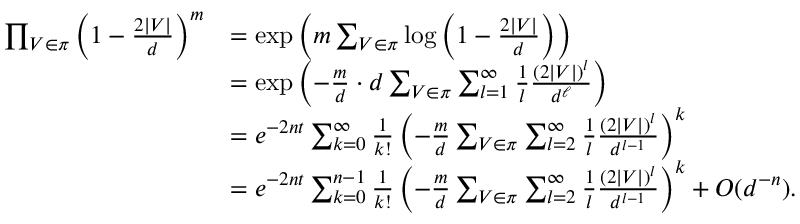<formula> <loc_0><loc_0><loc_500><loc_500>\begin{array} { r l } { \prod _ { V \in \pi } \left ( 1 - \frac { 2 | V | } { d } \right ) ^ { m } } & { = \exp \left ( m \sum _ { V \in \pi } \log \left ( 1 - \frac { 2 | V | } { d } \right ) \right ) } \\ & { = \exp \left ( - \frac { m } { d } \cdot d \sum _ { V \in \pi } \sum _ { l = 1 } ^ { \infty } \frac { 1 } { l } \frac { ( 2 | V | ) ^ { l } } { d ^ { \ell } } \right ) } \\ & { = e ^ { - 2 n t } \sum _ { k = 0 } ^ { \infty } \frac { 1 } { k ! } \left ( - \frac { m } { d } \sum _ { V \in \pi } \sum _ { l = 2 } ^ { \infty } \frac { 1 } { l } \frac { ( 2 | V | ) ^ { l } } { d ^ { l - 1 } } \right ) ^ { k } } \\ & { = e ^ { - 2 n t } \sum _ { k = 0 } ^ { n - 1 } \frac { 1 } { k ! } \left ( - \frac { m } { d } \sum _ { V \in \pi } \sum _ { l = 2 } ^ { \infty } \frac { 1 } { l } \frac { ( 2 | V | ) ^ { l } } { d ^ { l - 1 } } \right ) ^ { k } + O ( d ^ { - n } ) . } \end{array}</formula> 